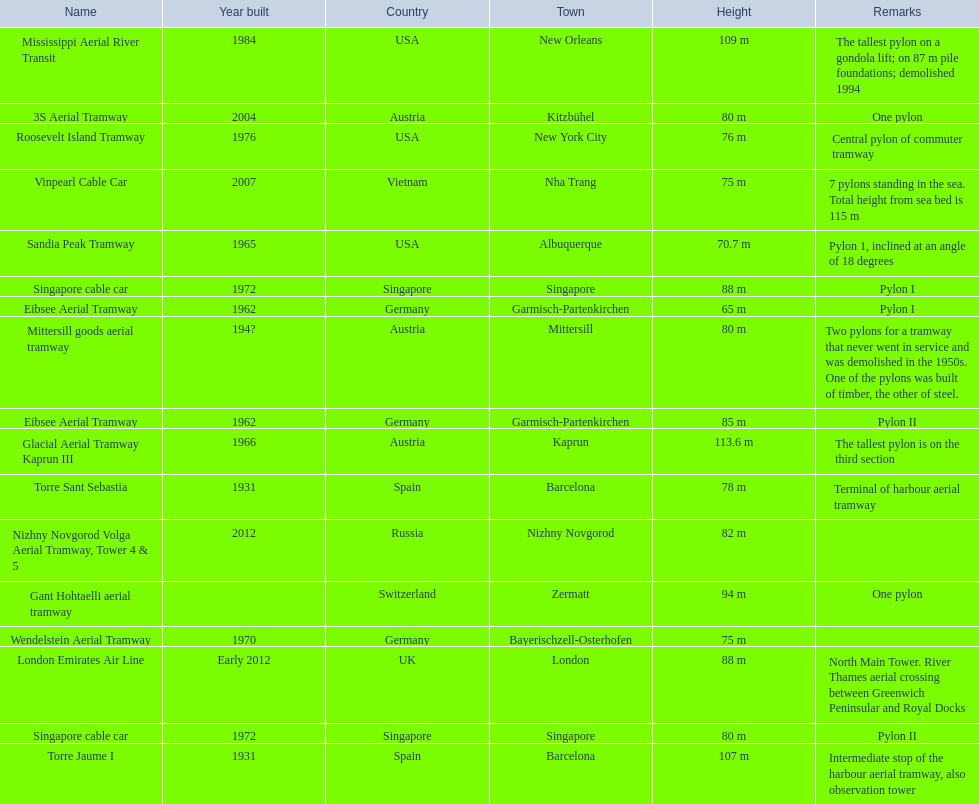How tall is the tallest pylon in metres? 113.6 m. 